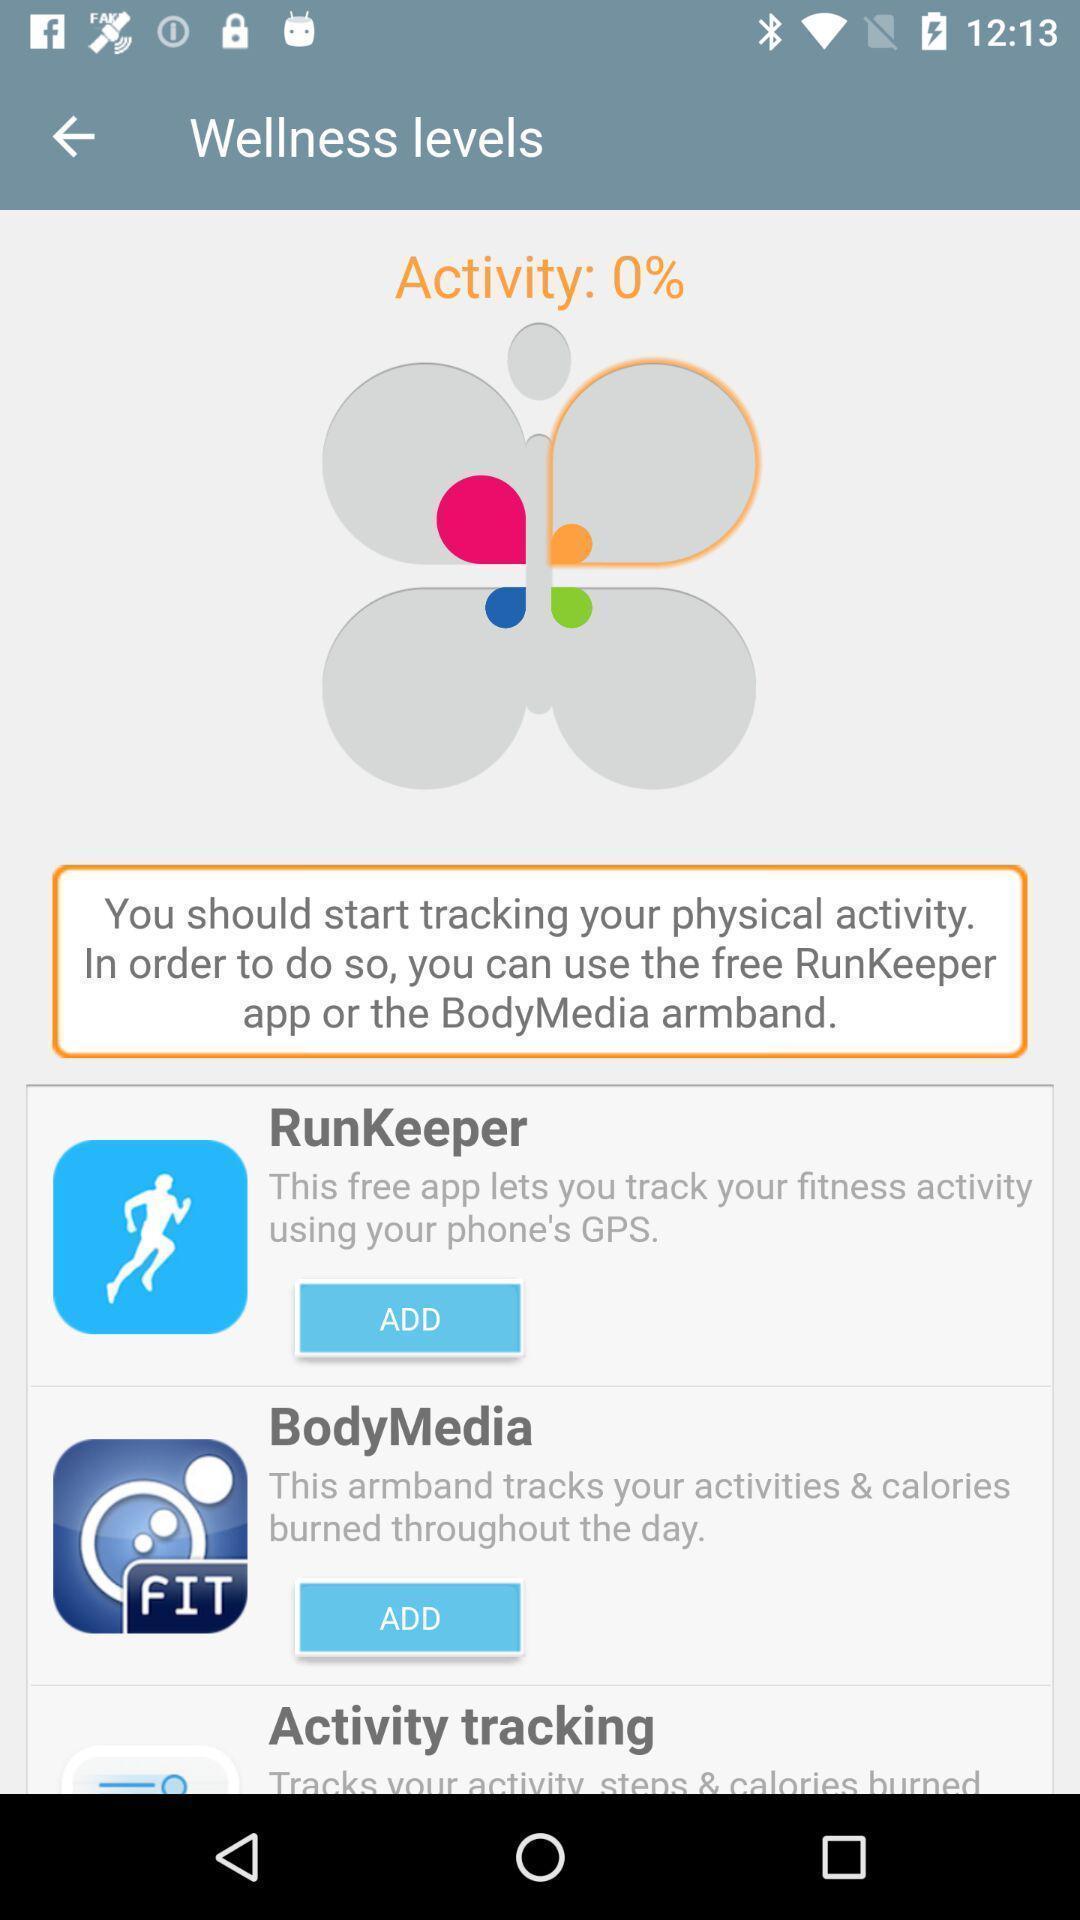Describe the visual elements of this screenshot. Page for health tracking app. 